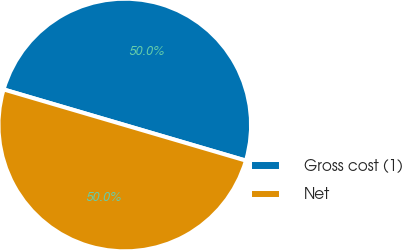<chart> <loc_0><loc_0><loc_500><loc_500><pie_chart><fcel>Gross cost (1)<fcel>Net<nl><fcel>50.0%<fcel>50.0%<nl></chart> 